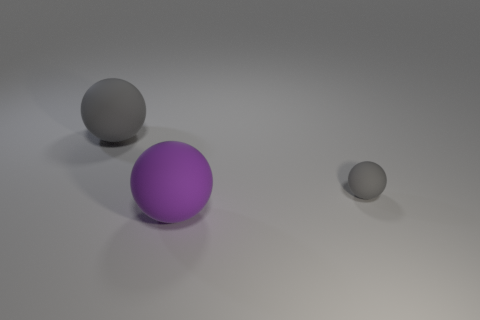Subtract all large balls. How many balls are left? 1 Add 1 large objects. How many objects exist? 4 Add 2 large gray rubber objects. How many large gray rubber objects exist? 3 Subtract 0 gray cubes. How many objects are left? 3 Subtract all tiny purple cylinders. Subtract all big purple spheres. How many objects are left? 2 Add 2 big things. How many big things are left? 4 